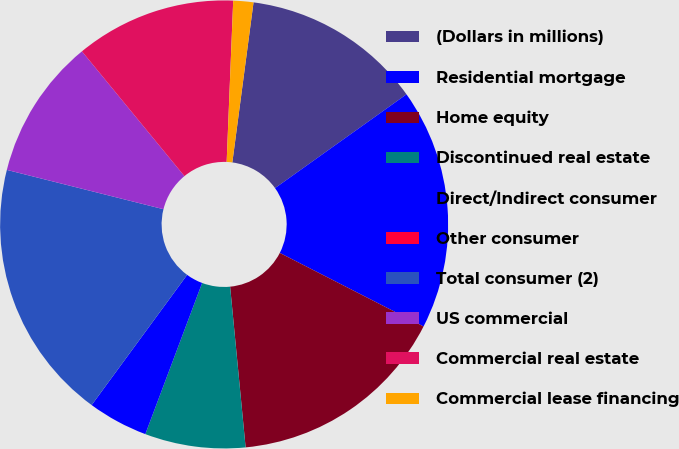<chart> <loc_0><loc_0><loc_500><loc_500><pie_chart><fcel>(Dollars in millions)<fcel>Residential mortgage<fcel>Home equity<fcel>Discontinued real estate<fcel>Direct/Indirect consumer<fcel>Other consumer<fcel>Total consumer (2)<fcel>US commercial<fcel>Commercial real estate<fcel>Commercial lease financing<nl><fcel>13.04%<fcel>17.39%<fcel>15.94%<fcel>7.25%<fcel>4.35%<fcel>0.0%<fcel>18.84%<fcel>10.14%<fcel>11.59%<fcel>1.45%<nl></chart> 